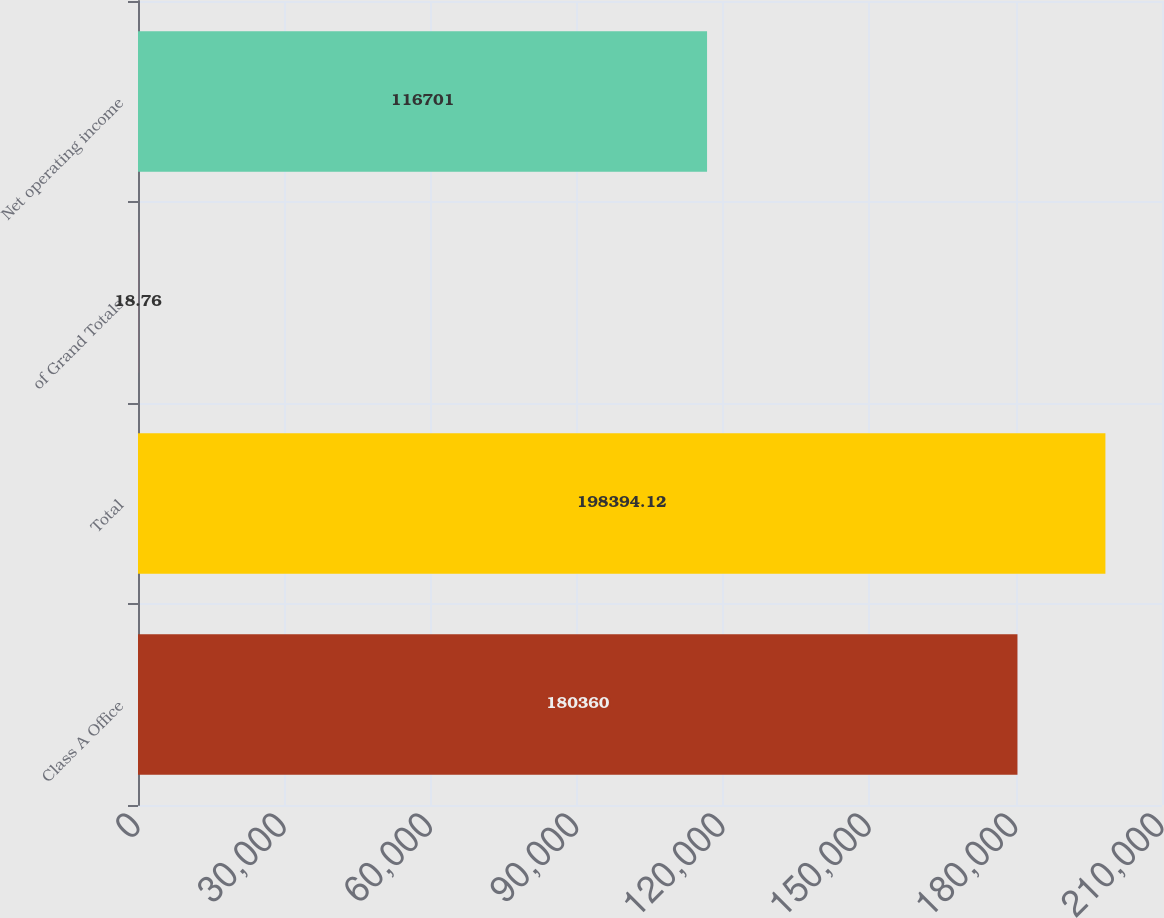Convert chart. <chart><loc_0><loc_0><loc_500><loc_500><bar_chart><fcel>Class A Office<fcel>Total<fcel>of Grand Totals<fcel>Net operating income<nl><fcel>180360<fcel>198394<fcel>18.76<fcel>116701<nl></chart> 